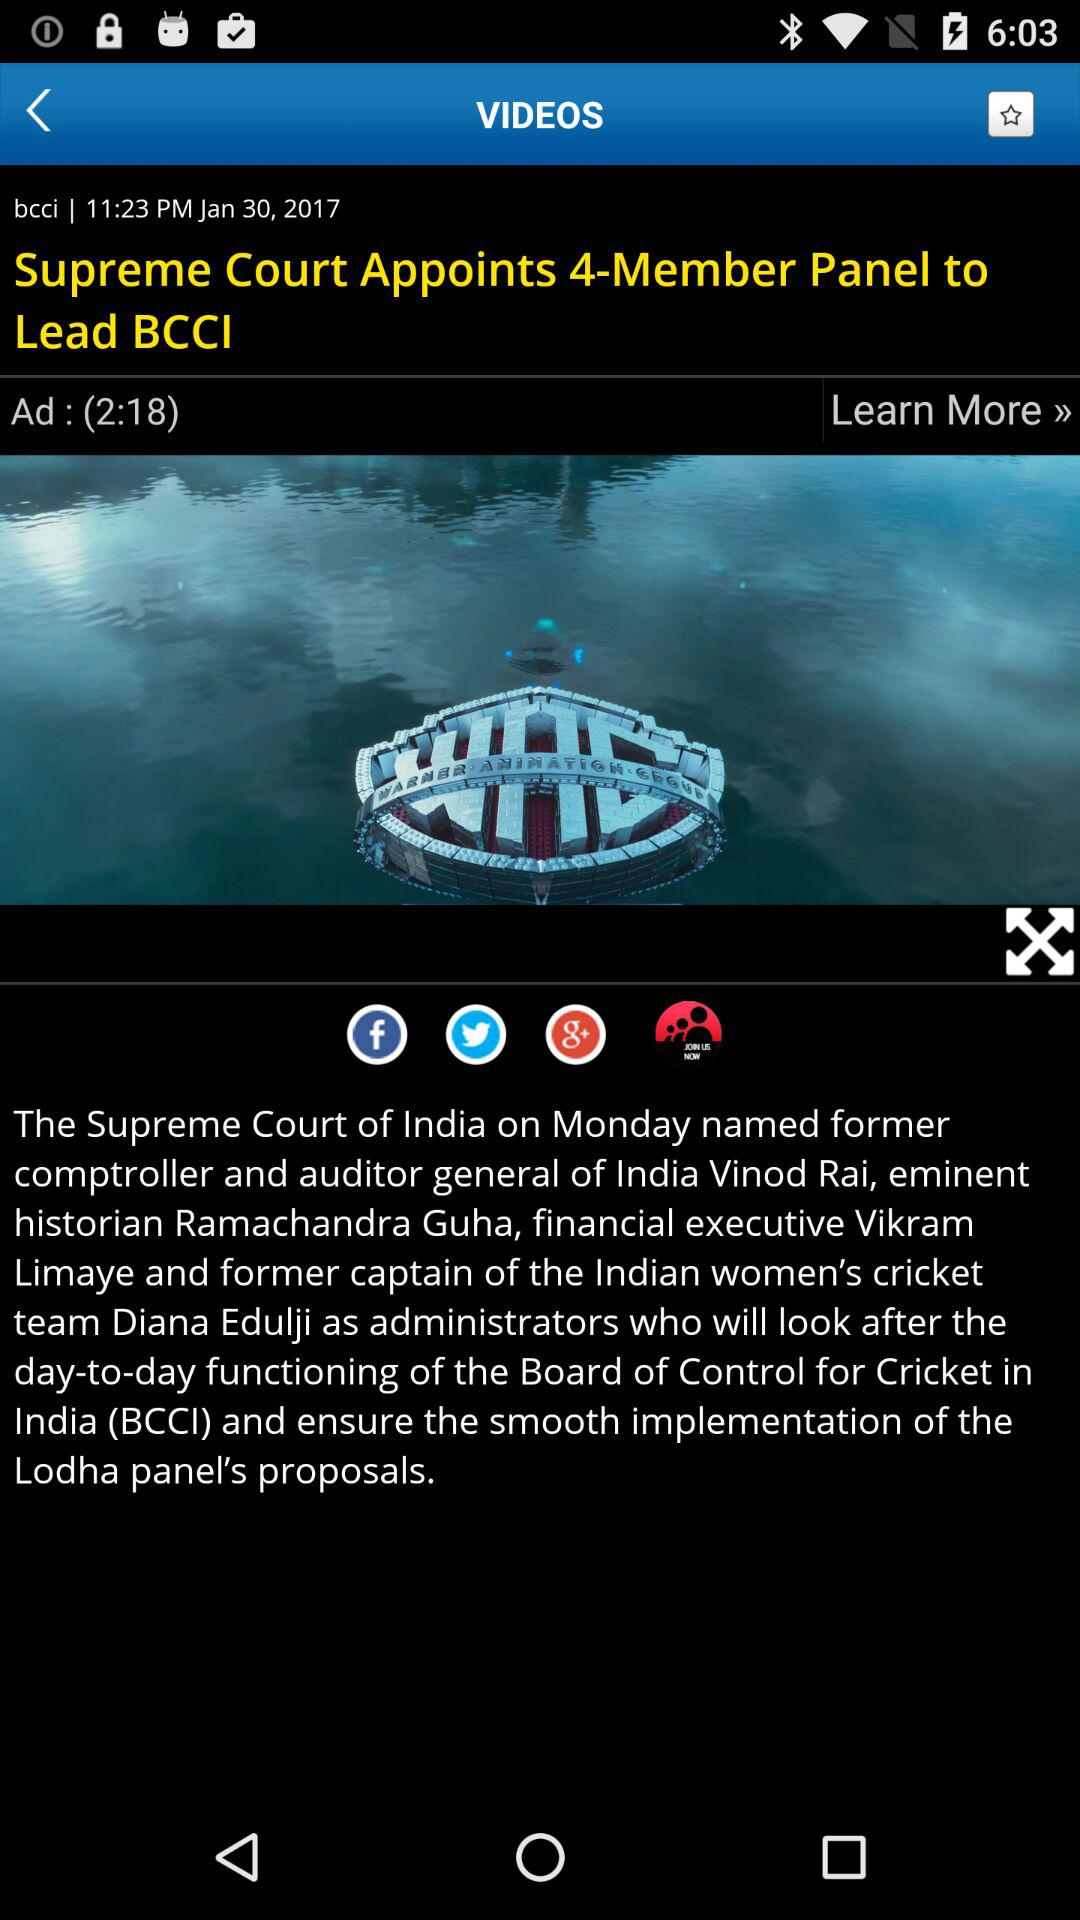How many members are appointed by the Supreme Court to lead BCCI? The Supreme Court appoints 4 members. 